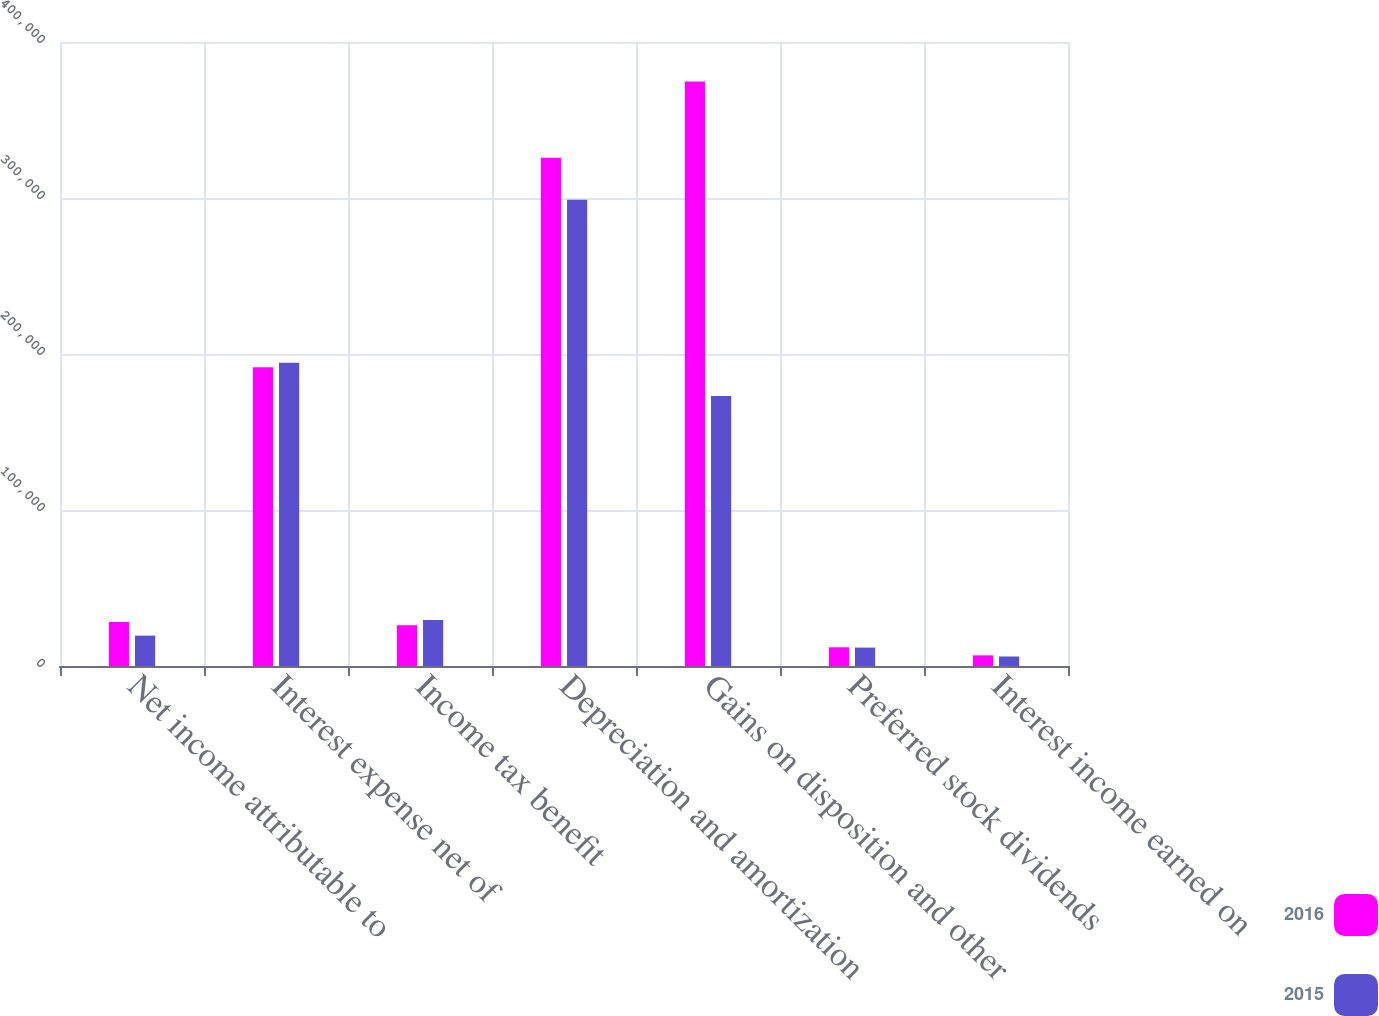<chart> <loc_0><loc_0><loc_500><loc_500><stacked_bar_chart><ecel><fcel>Net income attributable to<fcel>Interest expense net of<fcel>Income tax benefit<fcel>Depreciation and amortization<fcel>Gains on disposition and other<fcel>Preferred stock dividends<fcel>Interest income earned on<nl><fcel>2016<fcel>28242<fcel>191548<fcel>26159<fcel>325865<fcel>374757<fcel>11994<fcel>6825<nl><fcel>2015<fcel>19447<fcel>194423<fcel>29549<fcel>298880<fcel>173039<fcel>11794<fcel>6092<nl></chart> 